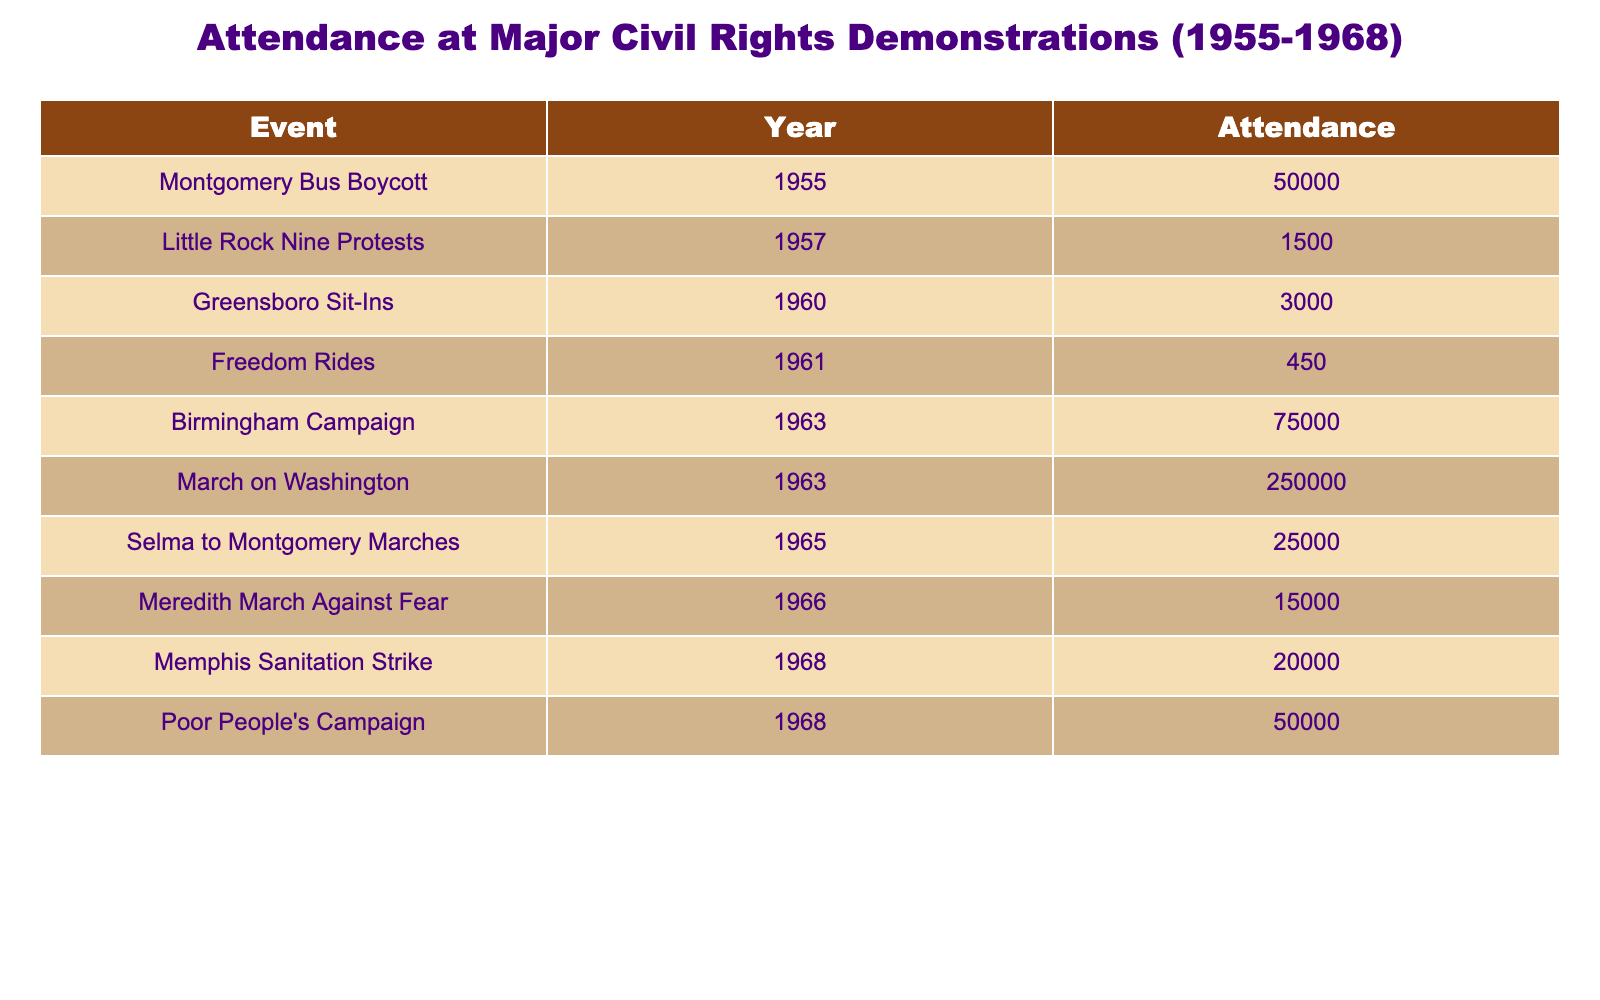What was the attendance for the March on Washington? The table lists the March on Washington in 1963 with an attendance of 250,000.
Answer: 250,000 Which event had the highest attendance? Looking at the table, the highest attendance is for the March on Washington in 1963 with 250,000 participants.
Answer: March on Washington What was the total attendance for the demonstrations in 1968? The events in 1968 are the Memphis Sanitation Strike (20,000) and the Poor People's Campaign (50,000). Adding those together gives 20,000 + 50,000 = 70,000 for 1968.
Answer: 70,000 How many people attended the Birmingham Campaign compared to the Freedom Rides? The Birmingham Campaign had an attendance of 75,000, and the Freedom Rides had 450. The difference is 75,000 - 450 = 74,550.
Answer: 74,550 Is the attendance at the Little Rock Nine Protests greater than that at the Greensboro Sit-Ins? The Little Rock Nine Protests had 1,500 attendees, while the Greensboro Sit-Ins drew 3,000. Since 1,500 is less than 3,000, this statement is false.
Answer: No What is the average attendance for the demonstrations in the years 1963 and 1965? For 1963, the Birmingham Campaign had 75,000 and the March on Washington had 250,000, totaling 325,000. For 1965, the Selma to Montgomery Marches had 25,000. The average is (325,000 + 25,000) / 3 = 350,000 / 3 = approximately 116,666.67.
Answer: Approximately 116,667 How does the attendance of the Montgomery Bus Boycott compare to the Memphis Sanitation Strike? The Montgomery Bus Boycott had 50,000 attendees, while the Memphis Sanitation Strike had 20,000. Since 50,000 is greater than 20,000, the Montgomery Bus Boycott had more attendees.
Answer: More attendees Was there a higher total attendance in 1963 or in 1965? In 1963, the Birmingham Campaign and March on Washington together had 75,000 + 250,000 = 325,000. In 1965, the Selma to Montgomery Marches had 25,000. Since 325,000 (1963) is greater than 25,000 (1965), 1963 had a higher total attendance.
Answer: 1963 had higher attendance Which event had the least attendance and how many attended it? The event with the least attendance is the Freedom Rides in 1961 with 450 people.
Answer: Freedom Rides, 450 attendees 